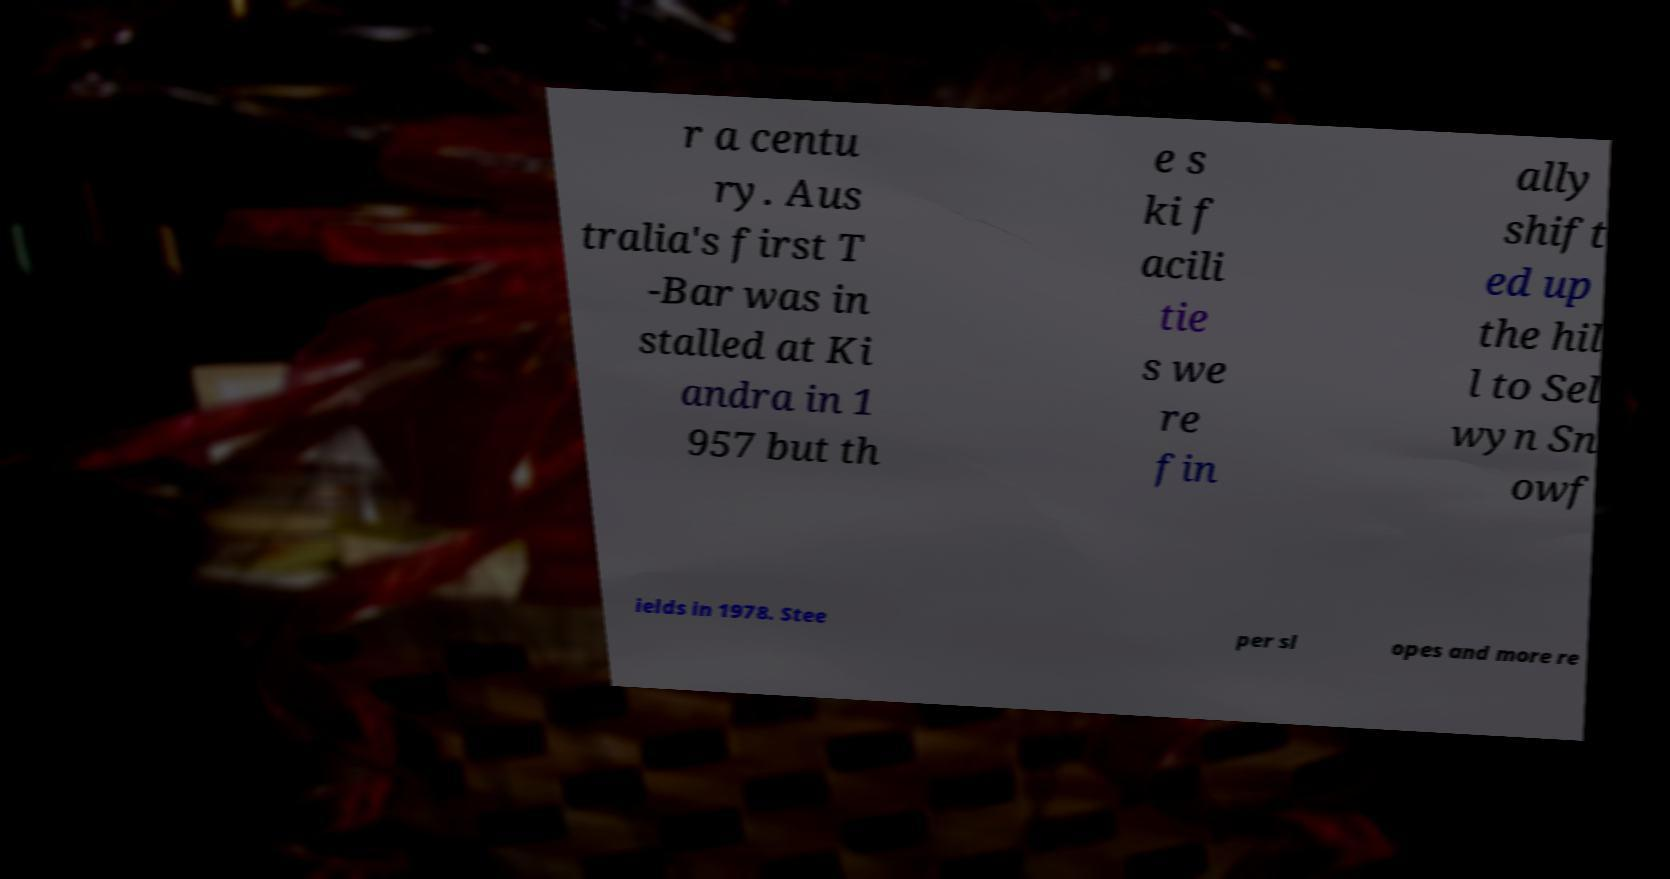I need the written content from this picture converted into text. Can you do that? r a centu ry. Aus tralia's first T -Bar was in stalled at Ki andra in 1 957 but th e s ki f acili tie s we re fin ally shift ed up the hil l to Sel wyn Sn owf ields in 1978. Stee per sl opes and more re 